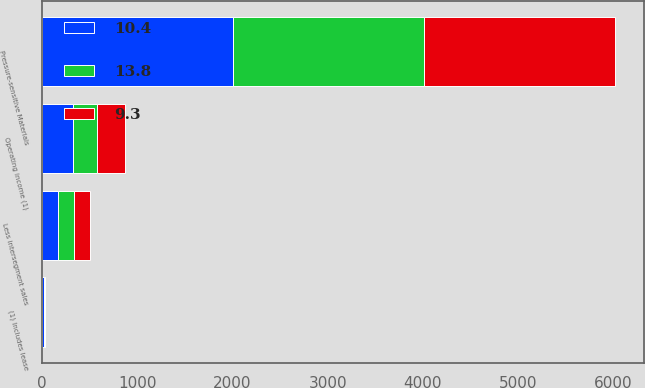<chart> <loc_0><loc_0><loc_500><loc_500><stacked_bar_chart><ecel><fcel>Pressure-sensitive Materials<fcel>Less intersegment sales<fcel>Operating income (1)<fcel>(1) Includes lease<nl><fcel>13.8<fcel>2008<fcel>172.4<fcel>252.3<fcel>10.4<nl><fcel>10.4<fcel>2007<fcel>164.9<fcel>318.7<fcel>13.8<nl><fcel>9.3<fcel>2006<fcel>161.5<fcel>301.6<fcel>9.3<nl></chart> 